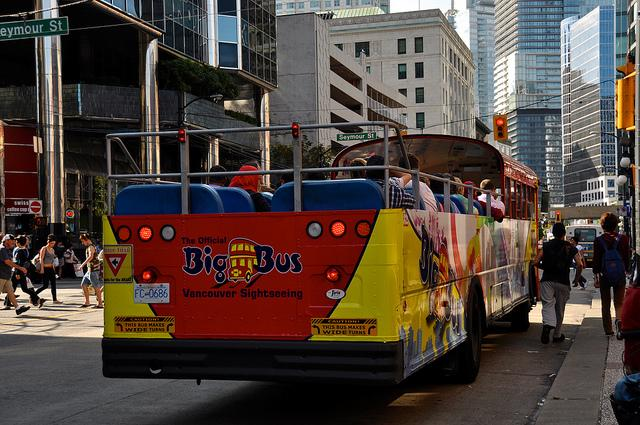What type of company owns the roofless bus?

Choices:
A) travel
B) city bus
C) tourist
D) sightseeing sightseeing 